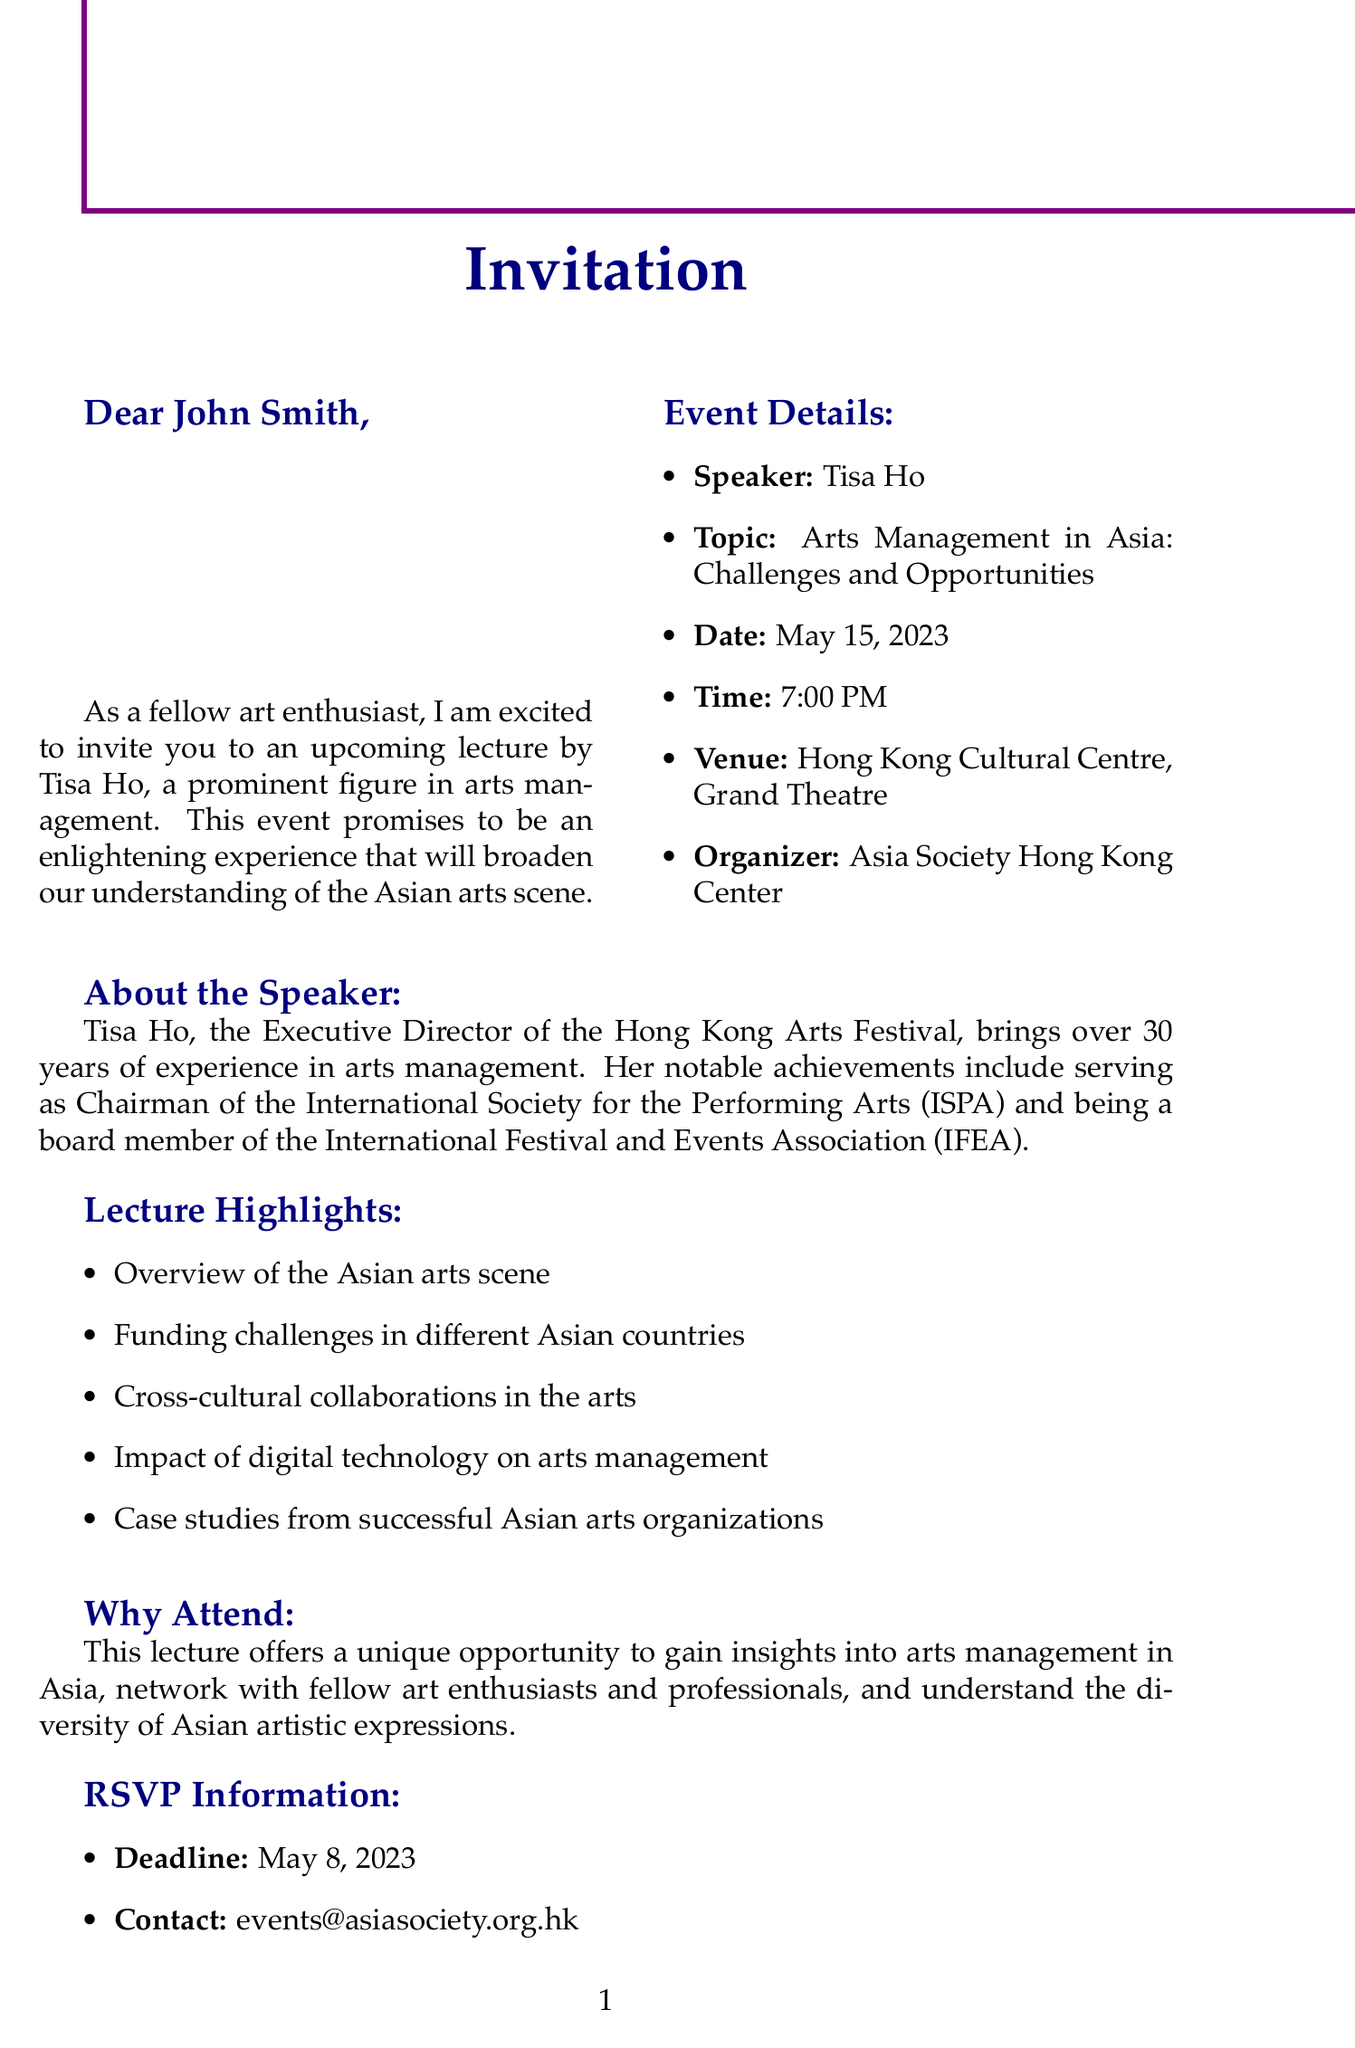What is the name of the speaker? The document states that the speaker is Tisa Ho.
Answer: Tisa Ho What is the date of the lecture? The date of the lecture, as mentioned in the document, is May 15, 2023.
Answer: May 15, 2023 Where will the event take place? The venue for the event is specified in the document as the Hong Kong Cultural Centre, Grand Theatre.
Answer: Hong Kong Cultural Centre, Grand Theatre What is one of Tisa Ho's notable achievements? The document lists several achievements, one of which is serving as Chairman of the International Society for the Performing Arts (ISPA).
Answer: Chairman of the International Society for the Performing Arts (ISPA) What time does the lecture start? According to the document, the lecture is scheduled to start at 7:00 PM.
Answer: 7:00 PM What is the RSVP deadline? The document specifies that the RSVP deadline is May 8, 2023.
Answer: May 8, 2023 What is the contact email for RSVP? The document provides the contact email as events@asiasociety.org.hk.
Answer: events@asiasociety.org.hk Why is this lecture relevant? The document notes that attending the lecture offers a unique opportunity to gain insights into arts management in Asia.
Answer: Gain insights into arts management in Asia What organization is hosting the lecture? The document indicates that the event is organized by the Asia Society Hong Kong Center.
Answer: Asia Society Hong Kong Center 